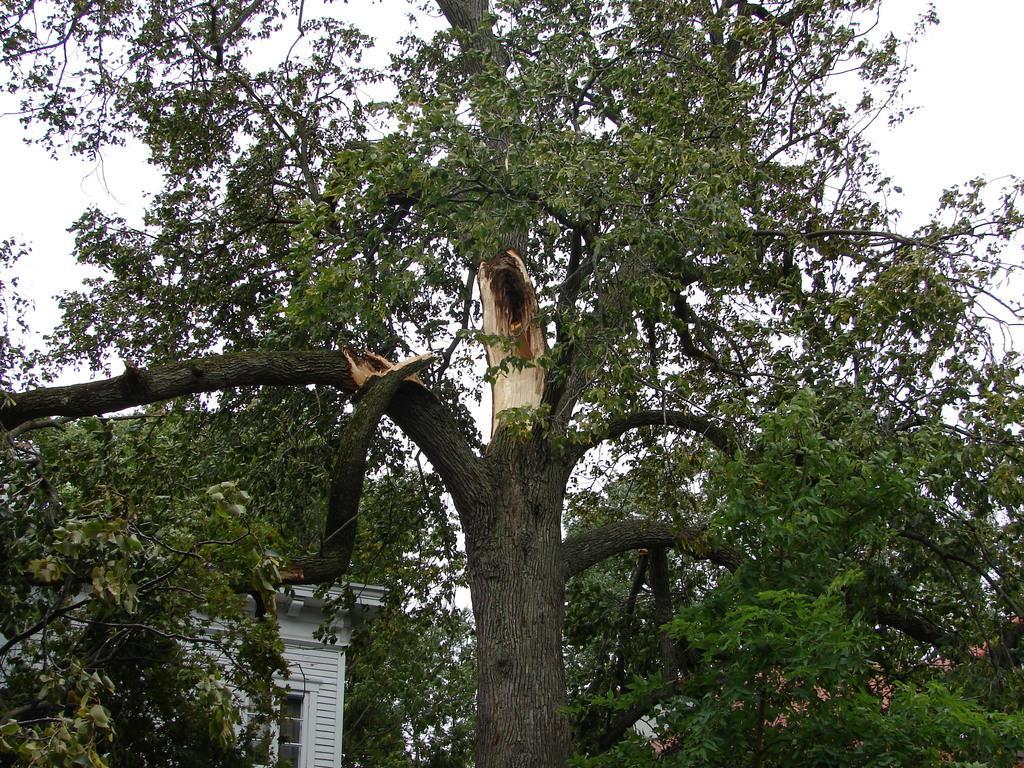Can you describe this image briefly? In this image in the foreground there is a tree, and in the background there are houses and some trees. 